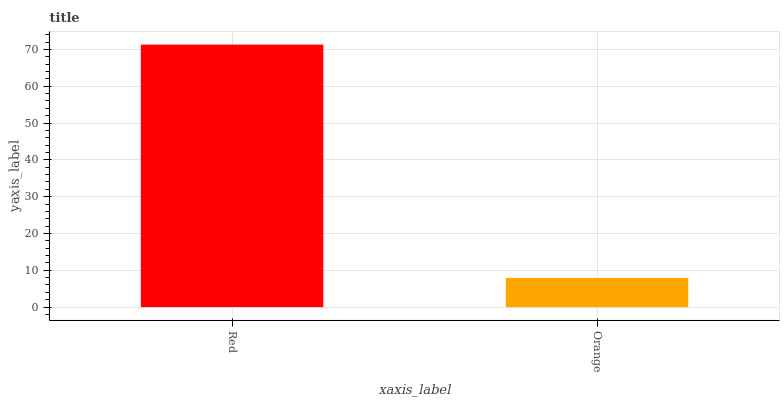Is Orange the minimum?
Answer yes or no. Yes. Is Red the maximum?
Answer yes or no. Yes. Is Orange the maximum?
Answer yes or no. No. Is Red greater than Orange?
Answer yes or no. Yes. Is Orange less than Red?
Answer yes or no. Yes. Is Orange greater than Red?
Answer yes or no. No. Is Red less than Orange?
Answer yes or no. No. Is Red the high median?
Answer yes or no. Yes. Is Orange the low median?
Answer yes or no. Yes. Is Orange the high median?
Answer yes or no. No. Is Red the low median?
Answer yes or no. No. 